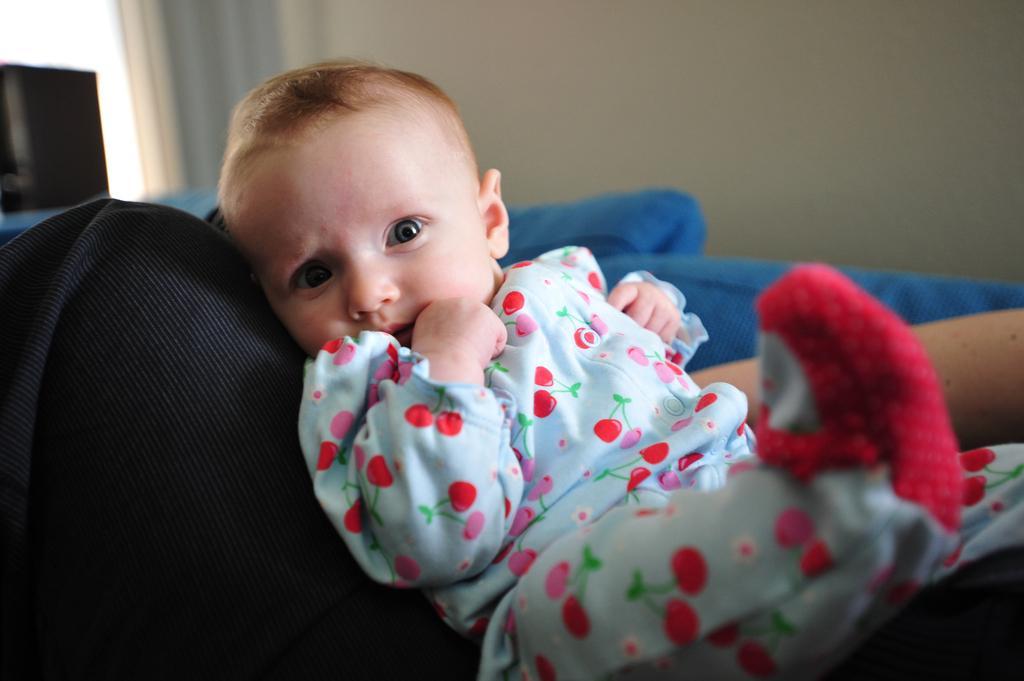Can you describe this image briefly? There is a baby sitting on an object. In the background, there is a blue color bed sheet and there is white wall. 